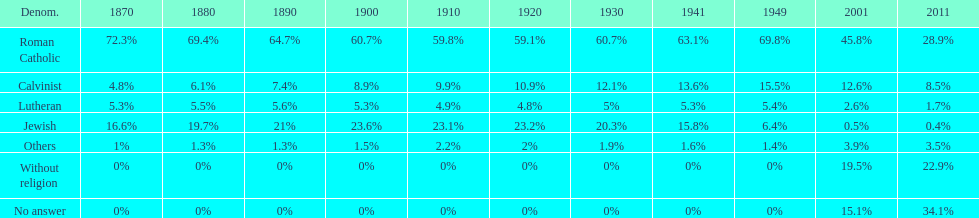Which denomination has the highest margin? Roman Catholic. 